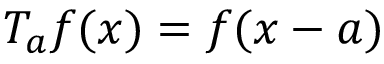Convert formula to latex. <formula><loc_0><loc_0><loc_500><loc_500>T _ { a } f ( x ) = f ( x - a )</formula> 